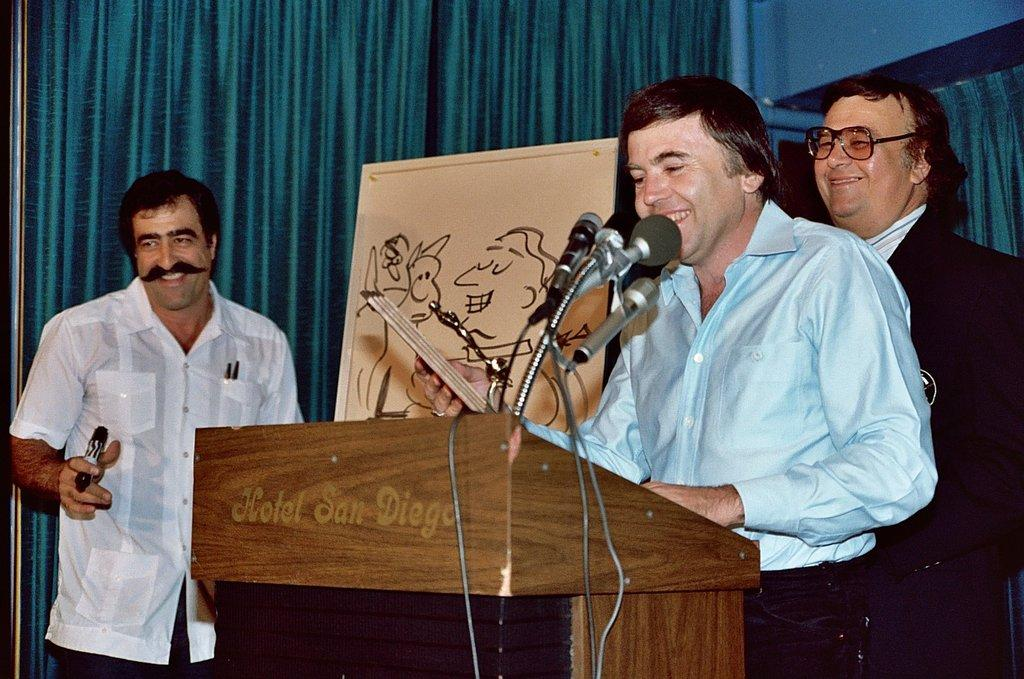How many people are in the image? There is a group of people in the image. What is the facial expression of the people in the image? The people are smiling. What object is present in the image that is typically used for speeches or presentations? There is a podium in the image. What objects are present in the image that are used for amplifying sound? There are microphones in the image. What can be seen in the background of the image? There is a curtain in the background of the image. What type of needle is being used to cause the end of the event in the image? There is no needle or event present in the image; it features a group of people, a podium, microphones, and a curtain. 